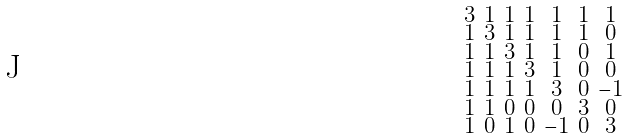<formula> <loc_0><loc_0><loc_500><loc_500>\begin{smallmatrix} 3 & 1 & 1 & 1 & 1 & 1 & 1 \\ 1 & 3 & 1 & 1 & 1 & 1 & 0 \\ 1 & 1 & 3 & 1 & 1 & 0 & 1 \\ 1 & 1 & 1 & 3 & 1 & 0 & 0 \\ 1 & 1 & 1 & 1 & 3 & 0 & - 1 \\ 1 & 1 & 0 & 0 & 0 & 3 & 0 \\ 1 & 0 & 1 & 0 & - 1 & 0 & 3 \end{smallmatrix}</formula> 